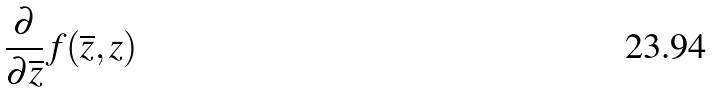<formula> <loc_0><loc_0><loc_500><loc_500>\frac { \partial } { \partial \overline { z } } f ( \overline { z } , z )</formula> 